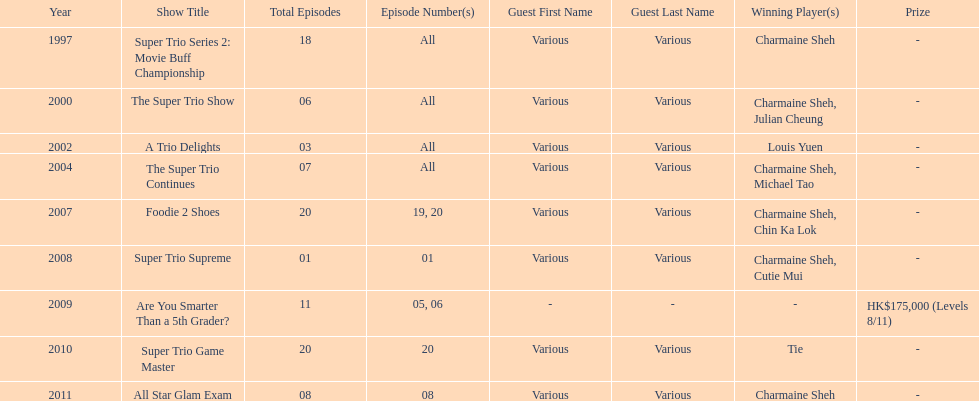What was the total number of trio series shows were charmaine sheh on? 6. 